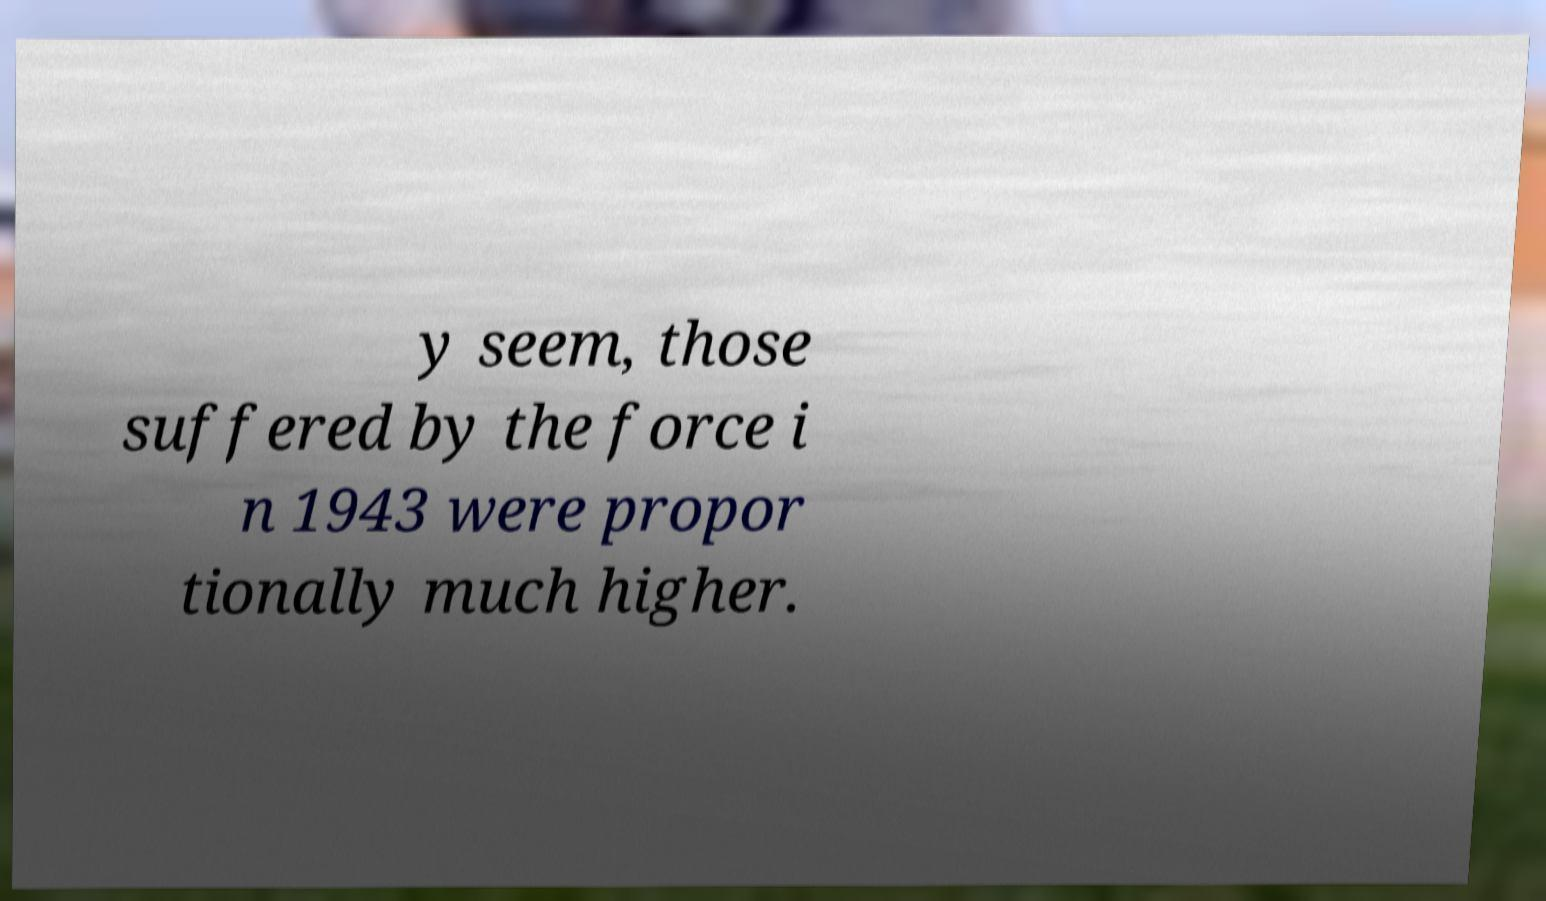Please read and relay the text visible in this image. What does it say? y seem, those suffered by the force i n 1943 were propor tionally much higher. 